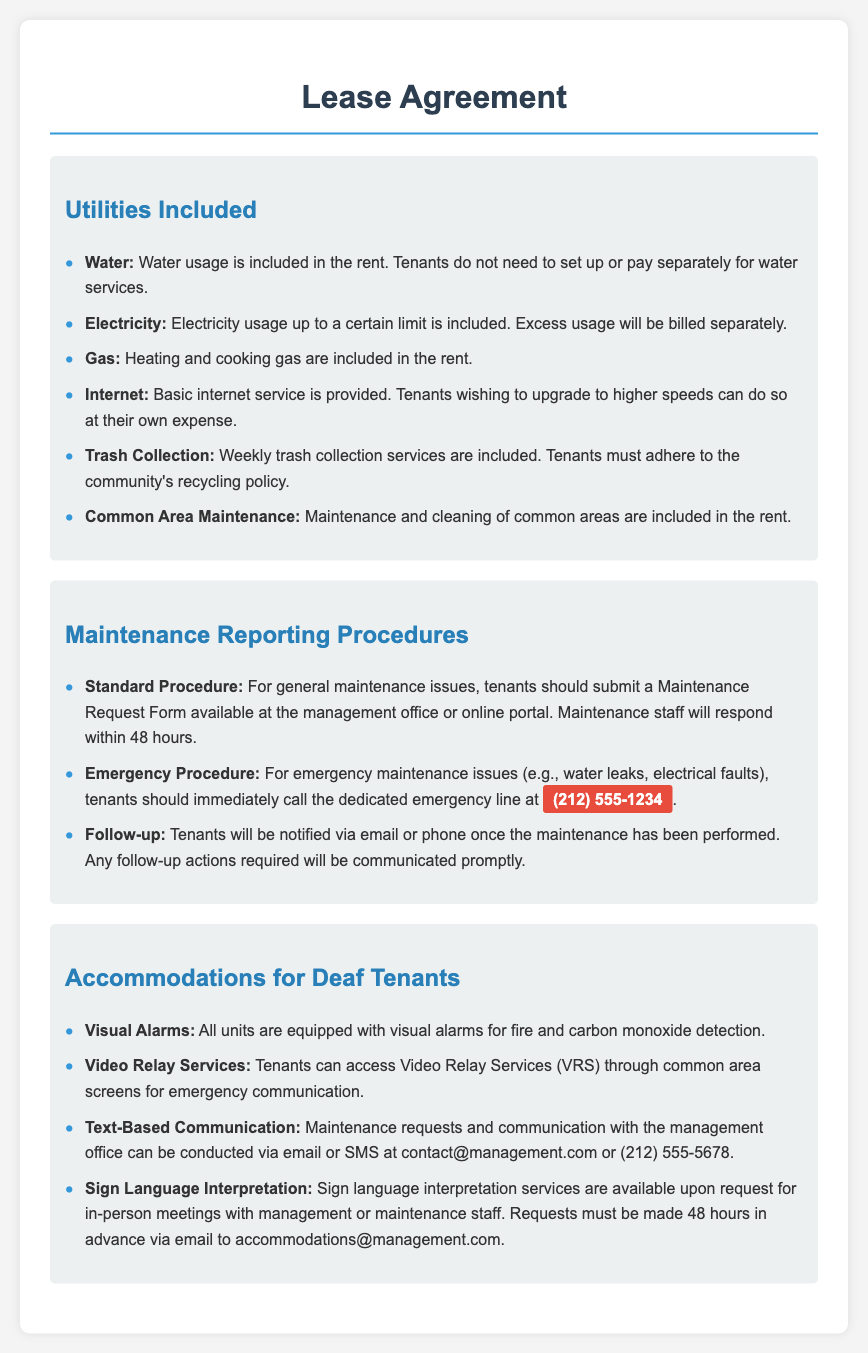what utilities are included in the rent? The utilities included in the rent as specified in the document are water, electricity, gas, internet, trash collection, and common area maintenance.
Answer: water, electricity, gas, internet, trash collection, common area maintenance what is the emergency maintenance contact number? The document states the emergency contact number for maintenance issues that arise is (212) 555-1234.
Answer: (212) 555-1234 how soon will maintenance staff respond to a standard maintenance request? The response time for standard maintenance requests, as detailed in the document, is within 48 hours.
Answer: 48 hours what type of service is provided for deaf tenants for emergency communication? The document mentions that visuals alarms and video relay services are provided to ensure emergency communication for deaf tenants.
Answer: Video Relay Services (VRS) how can maintenance requests be submitted? According to the document, maintenance requests can be submitted via a Maintenance Request Form or through email or SMS communication with the management office.
Answer: Maintenance Request Form, email, SMS how far in advance must a request for sign language interpretation be made? The required advance notice for requesting sign language interpretation services is specified in the document as 48 hours.
Answer: 48 hours 